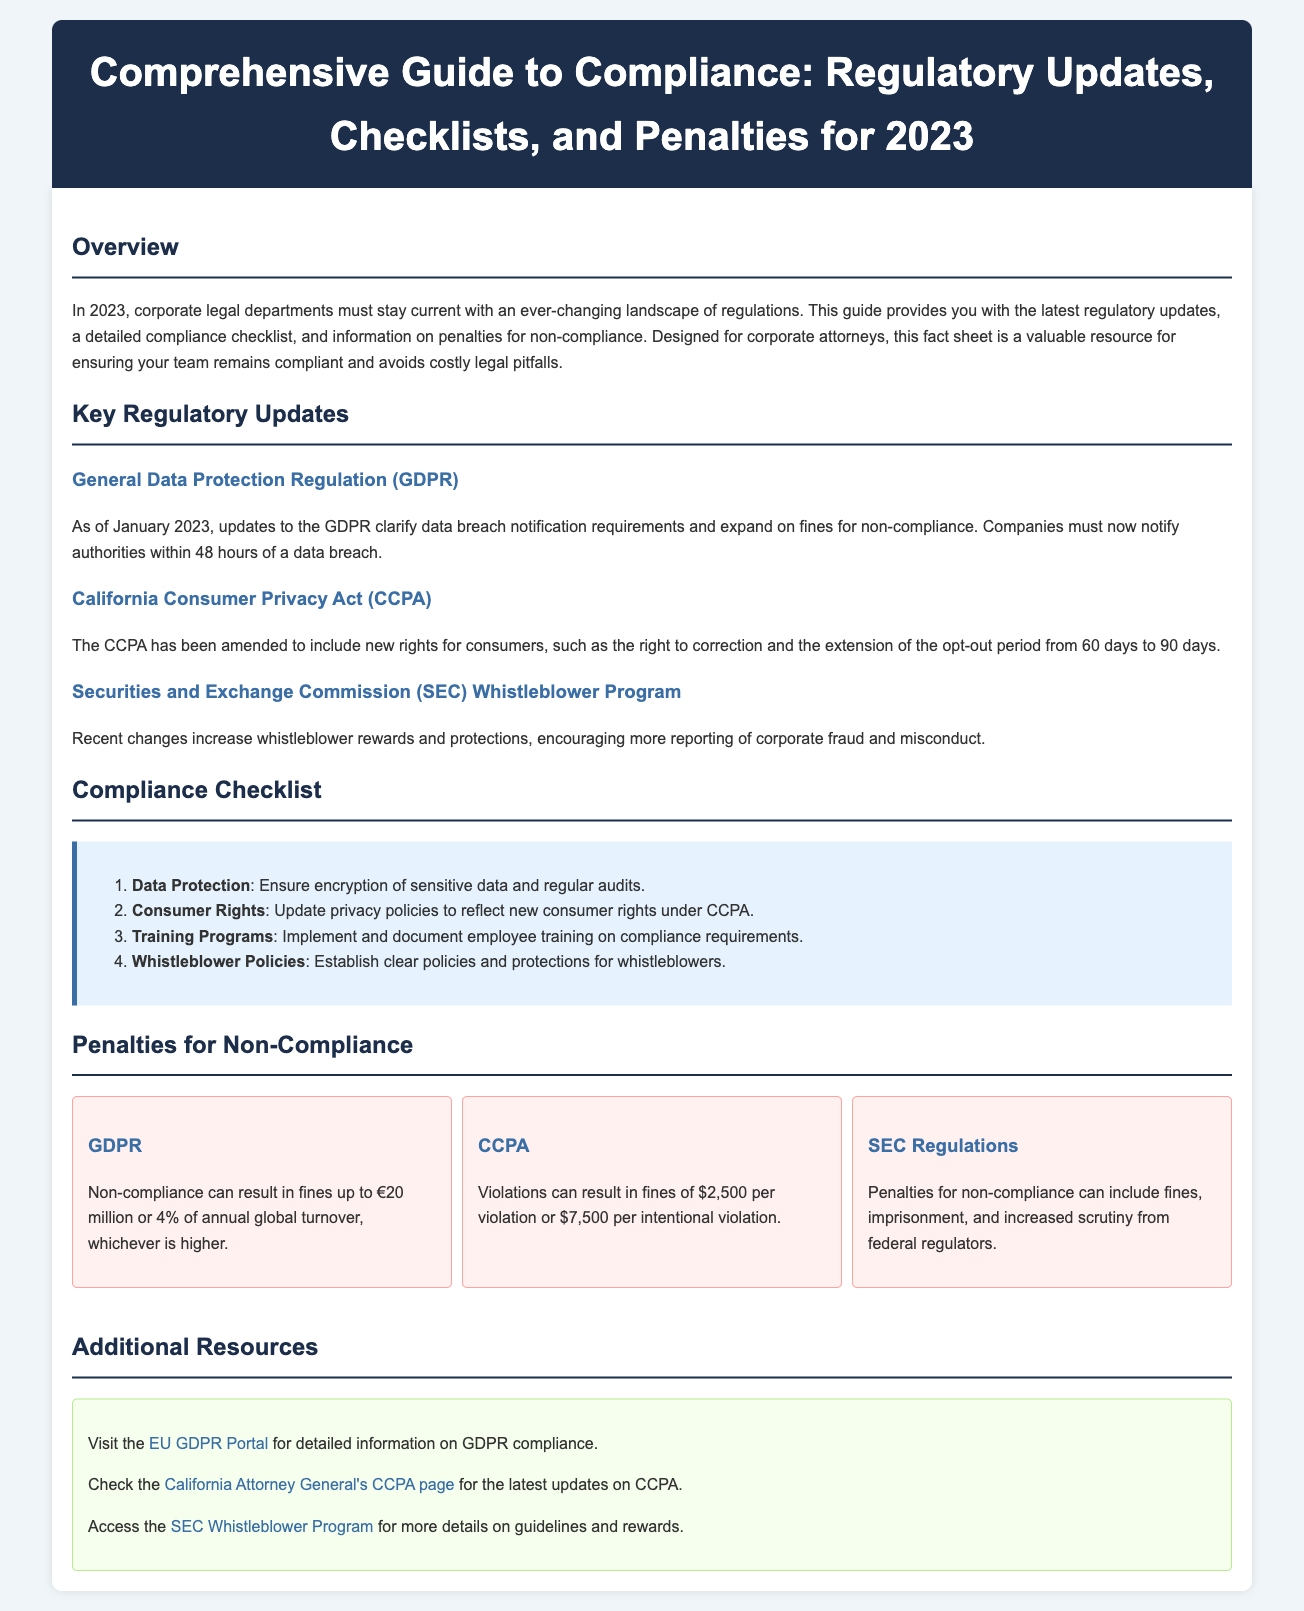What are the key regulatory updates for 2023? The key regulatory updates for 2023 include GDPR updates, CCPA amendments, and changes to the SEC Whistleblower Program.
Answer: GDPR, CCPA, SEC Whistleblower Program What is the penalty for GDPR non-compliance? Non-compliance can result in fines up to €20 million or 4% of annual global turnover, whichever is higher.
Answer: €20 million or 4% What new rights are included in the CCPA amendments? The CCPA has been amended to include new rights for consumers, such as the right to correction and the extension of the opt-out period.
Answer: Right to correction, extended opt-out period How many items are in the compliance checklist? The compliance checklist includes four specific items related to data protection, consumer rights, training programs, and whistleblower policies.
Answer: Four What do companies need to ensure regarding data protection? Companies must ensure encryption of sensitive data and conduct regular audits.
Answer: Encryption and audits What is the maximum fine for intentional CCPA violations? Violations can result in fines of $7,500 per intentional violation.
Answer: $7,500 What is the purpose of this comprehensive guide? The guide is designed to provide corporate legal departments with the latest regulatory updates, checklists, and penalty information.
Answer: Stay compliant What does the SEC Whistleblower Program aim to encourage? The recent changes increase whistleblower rewards and protections, encouraging more reporting of corporate fraud and misconduct.
Answer: Reporting corporate fraud Which organization provides detailed information on GDPR compliance? The EU GDPR Portal is suggested for detailed information on GDPR compliance.
Answer: EU GDPR Portal 